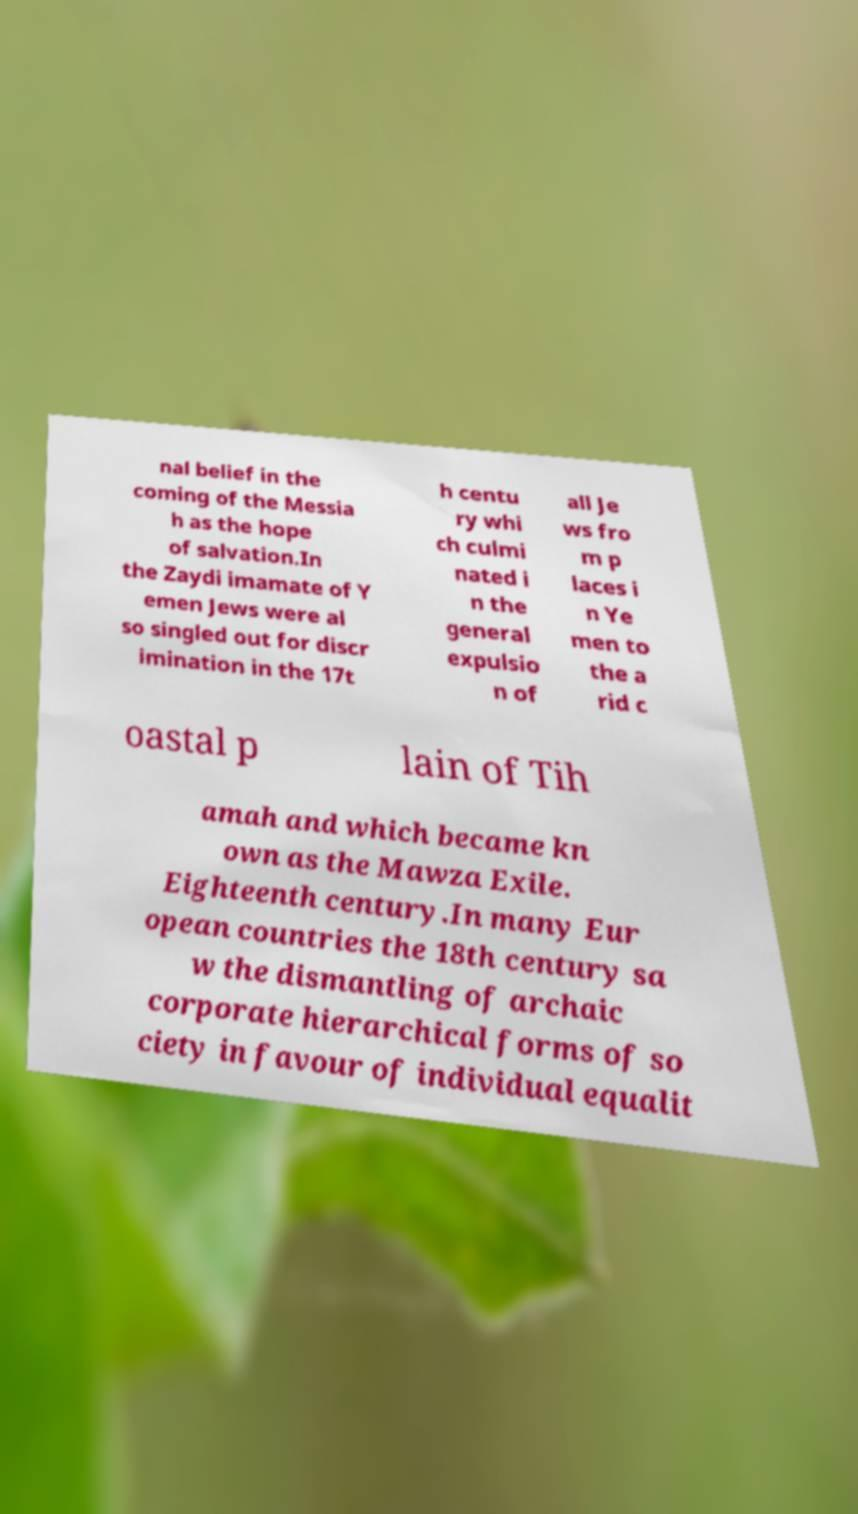What messages or text are displayed in this image? I need them in a readable, typed format. nal belief in the coming of the Messia h as the hope of salvation.In the Zaydi imamate of Y emen Jews were al so singled out for discr imination in the 17t h centu ry whi ch culmi nated i n the general expulsio n of all Je ws fro m p laces i n Ye men to the a rid c oastal p lain of Tih amah and which became kn own as the Mawza Exile. Eighteenth century.In many Eur opean countries the 18th century sa w the dismantling of archaic corporate hierarchical forms of so ciety in favour of individual equalit 